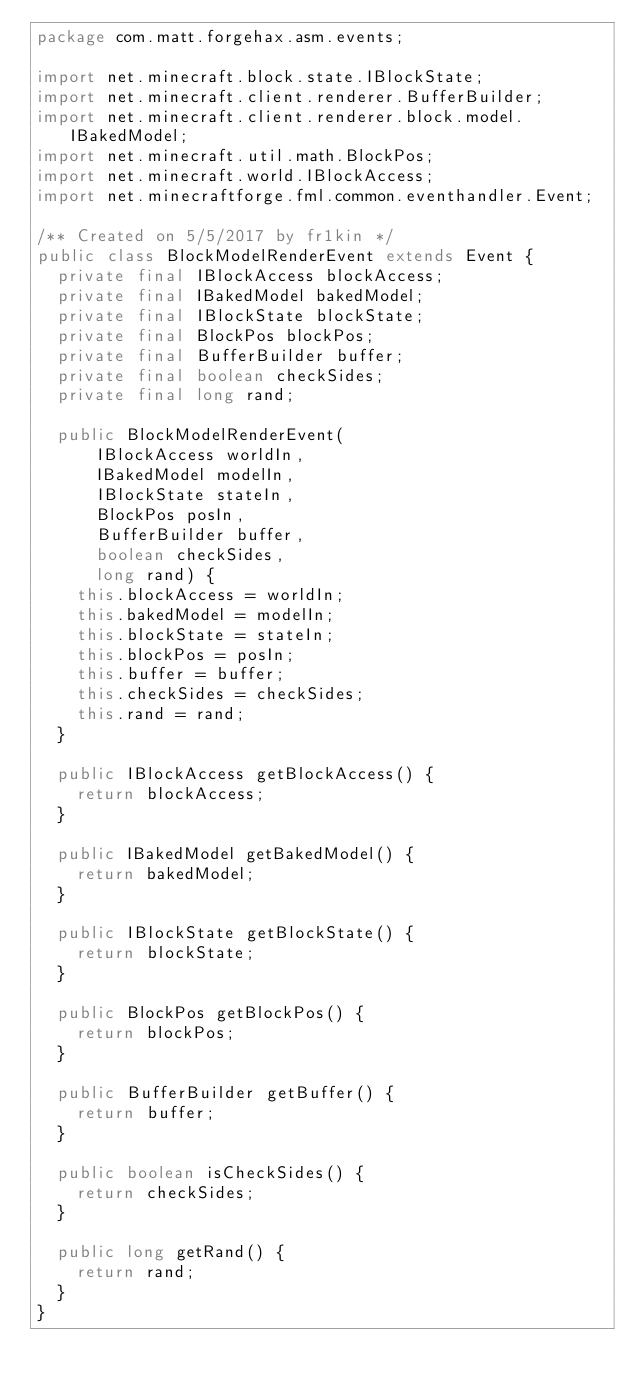Convert code to text. <code><loc_0><loc_0><loc_500><loc_500><_Java_>package com.matt.forgehax.asm.events;

import net.minecraft.block.state.IBlockState;
import net.minecraft.client.renderer.BufferBuilder;
import net.minecraft.client.renderer.block.model.IBakedModel;
import net.minecraft.util.math.BlockPos;
import net.minecraft.world.IBlockAccess;
import net.minecraftforge.fml.common.eventhandler.Event;

/** Created on 5/5/2017 by fr1kin */
public class BlockModelRenderEvent extends Event {
  private final IBlockAccess blockAccess;
  private final IBakedModel bakedModel;
  private final IBlockState blockState;
  private final BlockPos blockPos;
  private final BufferBuilder buffer;
  private final boolean checkSides;
  private final long rand;

  public BlockModelRenderEvent(
      IBlockAccess worldIn,
      IBakedModel modelIn,
      IBlockState stateIn,
      BlockPos posIn,
      BufferBuilder buffer,
      boolean checkSides,
      long rand) {
    this.blockAccess = worldIn;
    this.bakedModel = modelIn;
    this.blockState = stateIn;
    this.blockPos = posIn;
    this.buffer = buffer;
    this.checkSides = checkSides;
    this.rand = rand;
  }

  public IBlockAccess getBlockAccess() {
    return blockAccess;
  }

  public IBakedModel getBakedModel() {
    return bakedModel;
  }

  public IBlockState getBlockState() {
    return blockState;
  }

  public BlockPos getBlockPos() {
    return blockPos;
  }

  public BufferBuilder getBuffer() {
    return buffer;
  }

  public boolean isCheckSides() {
    return checkSides;
  }

  public long getRand() {
    return rand;
  }
}
</code> 